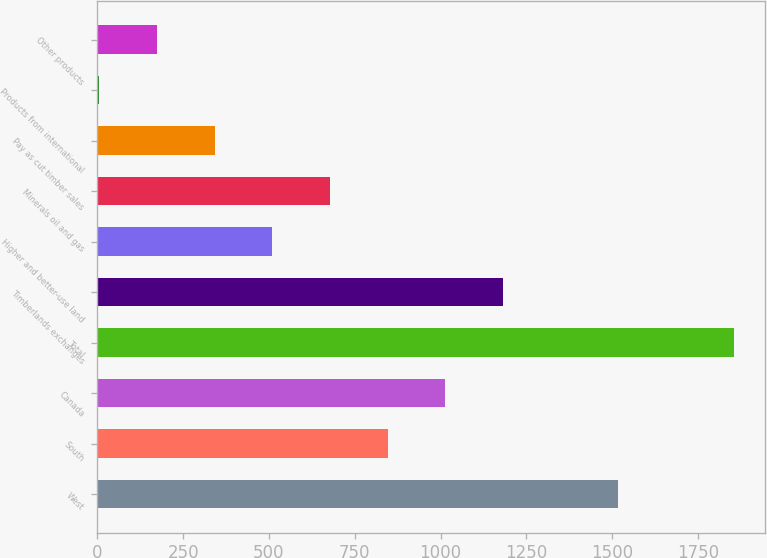<chart> <loc_0><loc_0><loc_500><loc_500><bar_chart><fcel>West<fcel>South<fcel>Canada<fcel>Total<fcel>Timberlands exchanges<fcel>Higher and better-use land<fcel>Minerals oil and gas<fcel>Pay as cut timber sales<fcel>Products from international<fcel>Other products<nl><fcel>1518<fcel>846<fcel>1014<fcel>1854<fcel>1182<fcel>510<fcel>678<fcel>342<fcel>6<fcel>174<nl></chart> 